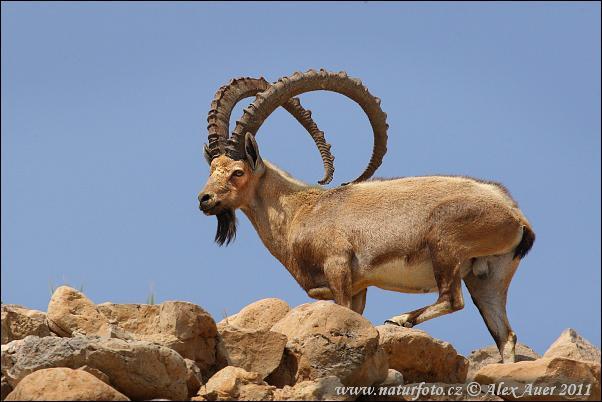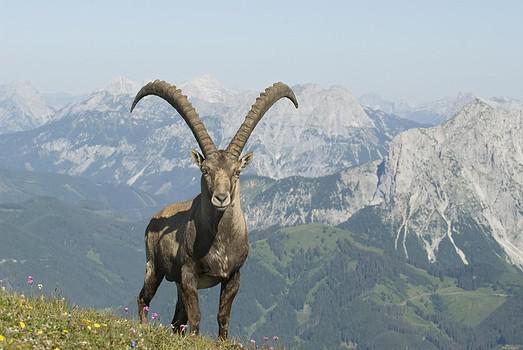The first image is the image on the left, the second image is the image on the right. Evaluate the accuracy of this statement regarding the images: "One animal is standing on two feet in the image on the left.". Is it true? Answer yes or no. No. The first image is the image on the left, the second image is the image on the right. Given the left and right images, does the statement "There's no more than one mountain goat in the right image." hold true? Answer yes or no. Yes. 